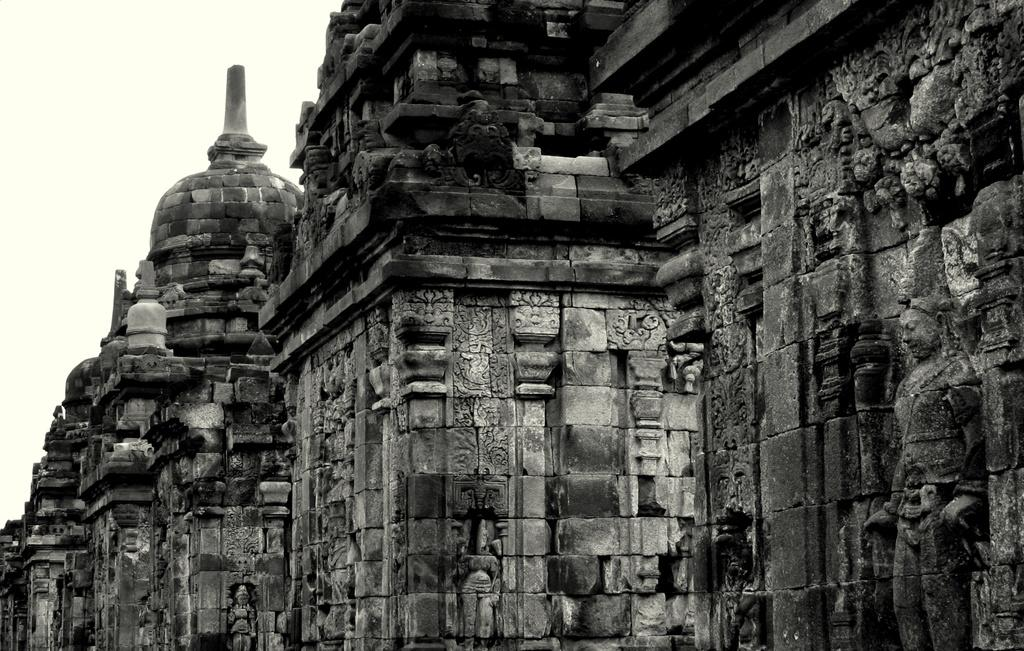What type of structure is depicted in the image? There is a historical building in the image. What can be seen in the background of the image? The sky is visible in the background of the image. What type of shirt is being worn by the oven in the image? There is no oven or shirt present in the image; it features a historical building and the sky. 